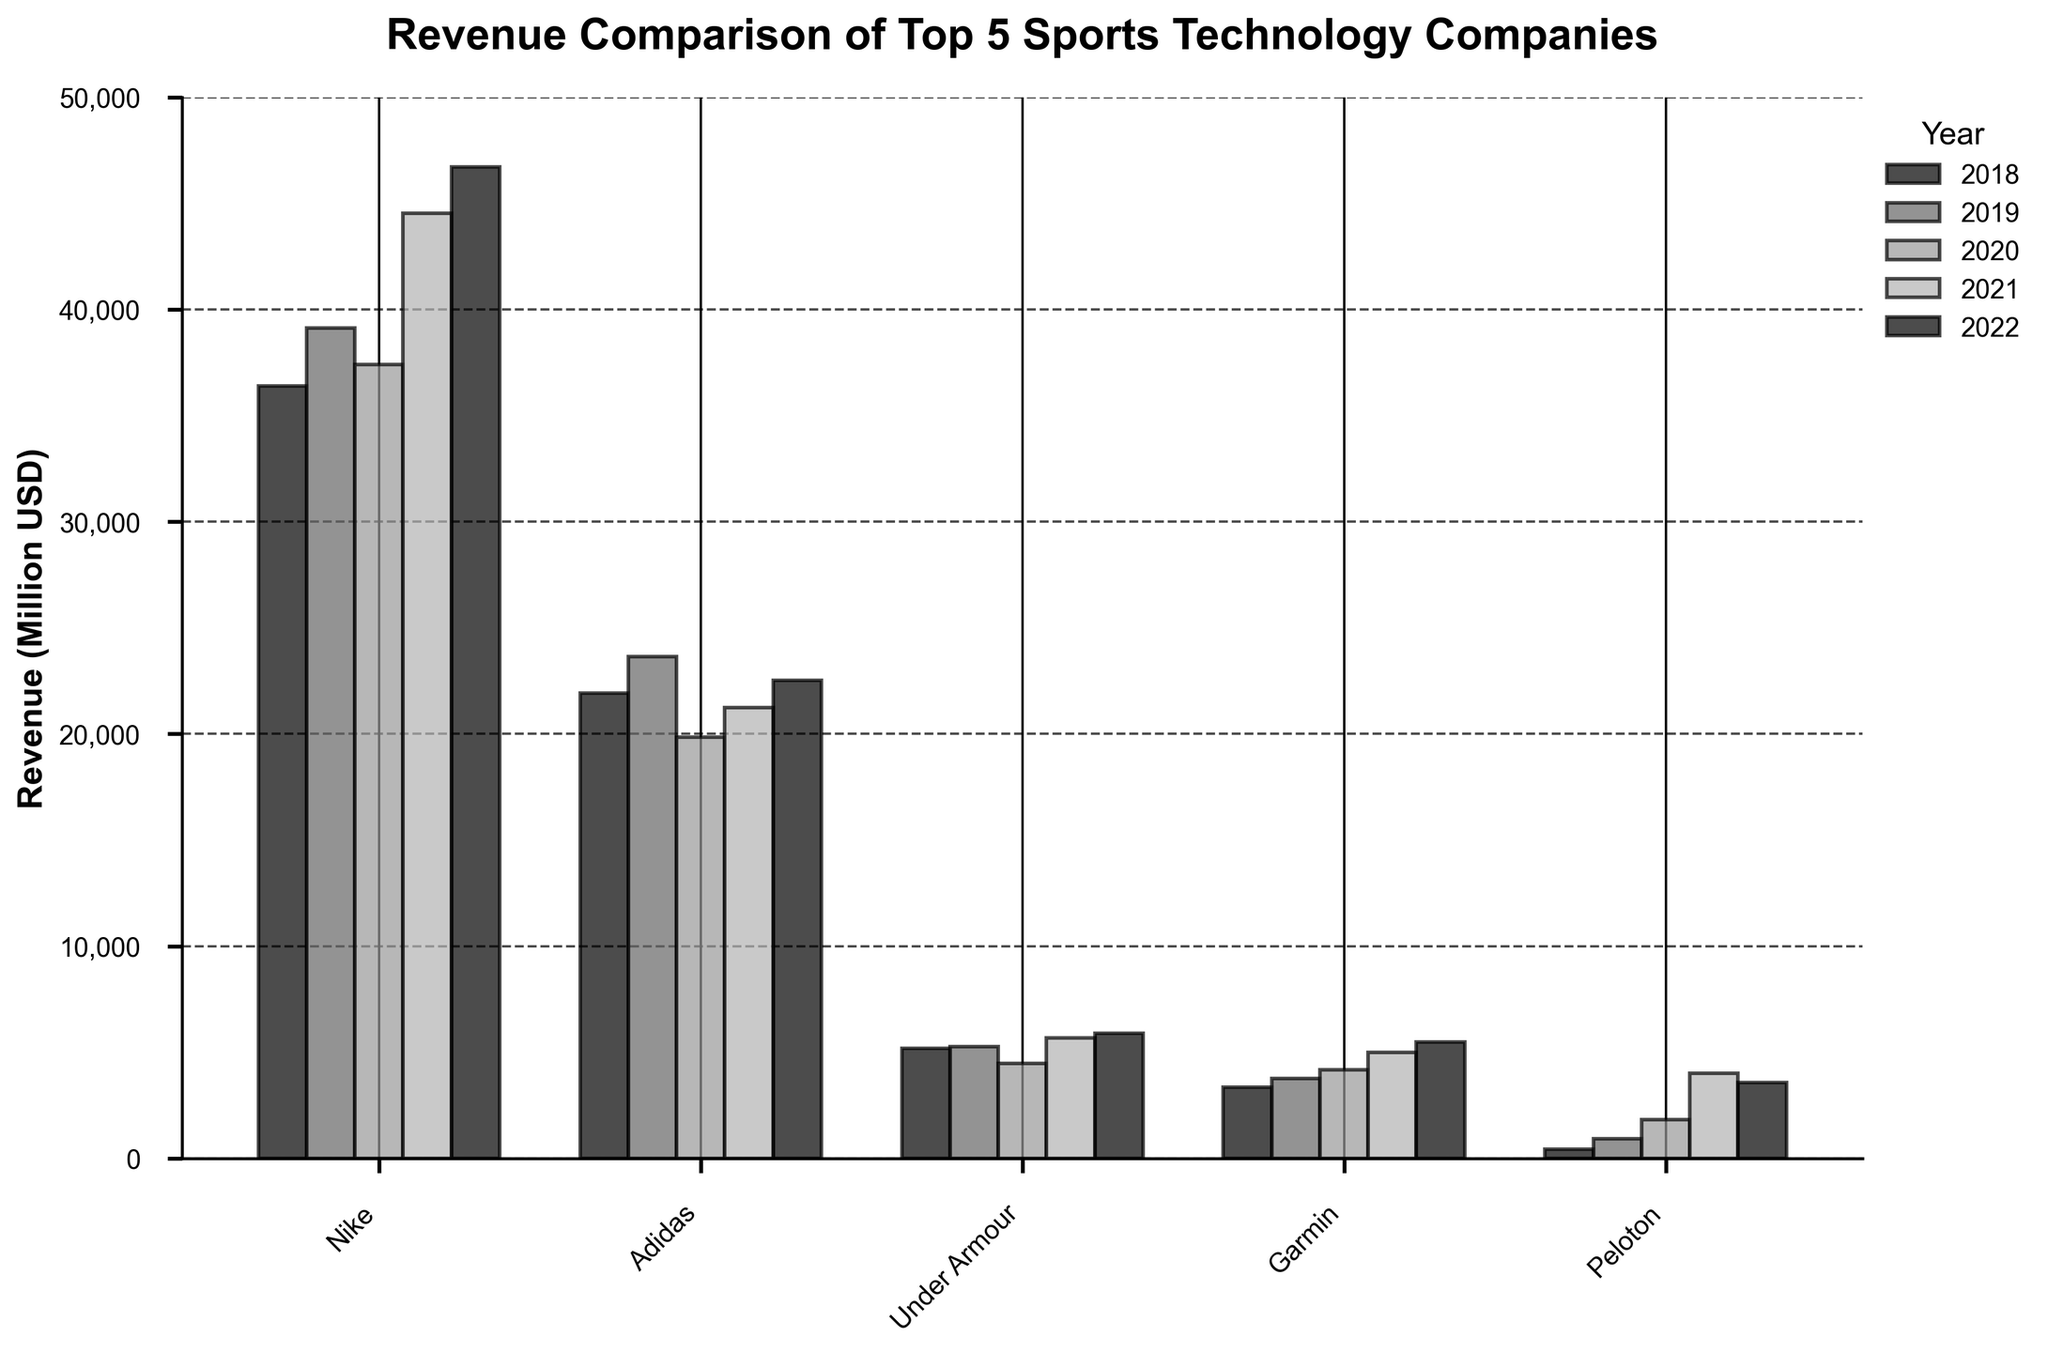Which company had the highest revenue in 2021? Look at the bar heights for 2021 (labelled on the legend) and identify the tallest one, which belongs to Nike.
Answer: Nike Which company showed the most consistent revenue growth from 2018 to 2022? Compare the trends in each company's bars over the given years. Garmin shows steady growth every year without significant drops or spikes.
Answer: Garmin What is the difference in revenue between Nike and Adidas in 2022? Find the bar height for both Nike and Adidas in 2022, then subtract Adidas's revenue from Nike's revenue: 46710 - 22511.
Answer: 24199 Which two companies had the closest revenue figures in 2019, and what is their difference? Compare the bar heights of all companies in 2019, and find the pair with the smallest difference. Under Armour and Garmin are closest with values 5267 and 3758, respectively (5267 - 3758).
Answer: Under Armour and Garmin, 1509 What is the total revenue generated by Peloton from 2018 to 2022? Sum up the revenue for Peloton across all five years: 435 + 915 + 1826 + 4021 + 3582.
Answer: 10779 Which company had the largest drop in revenue from one year to the next, and what are those years? Examine the differences between each year's bar for all companies. Adidas had the largest drop from 2019 (23640) to 2020 (19844).
Answer: Adidas, 2019 to 2020 How does Peloton's revenue in 2021 compare to Garmin's revenue in 2021? Compare the heights of the bars for Peloton and Garmin in 2021. Peloton's revenue (4021) is less than Garmin's revenue (4983).
Answer: Peloton's revenue is less than Garmin's Which year showed the highest revenue for Under Armour? Identify the tallest bar for Under Armour across all years. The highest bar is in 2022.
Answer: 2022 By how much did Nike's revenue increase from 2018 to 2022? Subtract the 2018 revenue from the 2022 revenue for Nike: 46710 - 36397.
Answer: 10313 Which company experienced a revenue decline in 2022 compared to 2021? Compare the bar heights for each company between 2021 and 2022. Peloton's bar is lower in 2022 (3582) than in 2021 (4021).
Answer: Peloton 